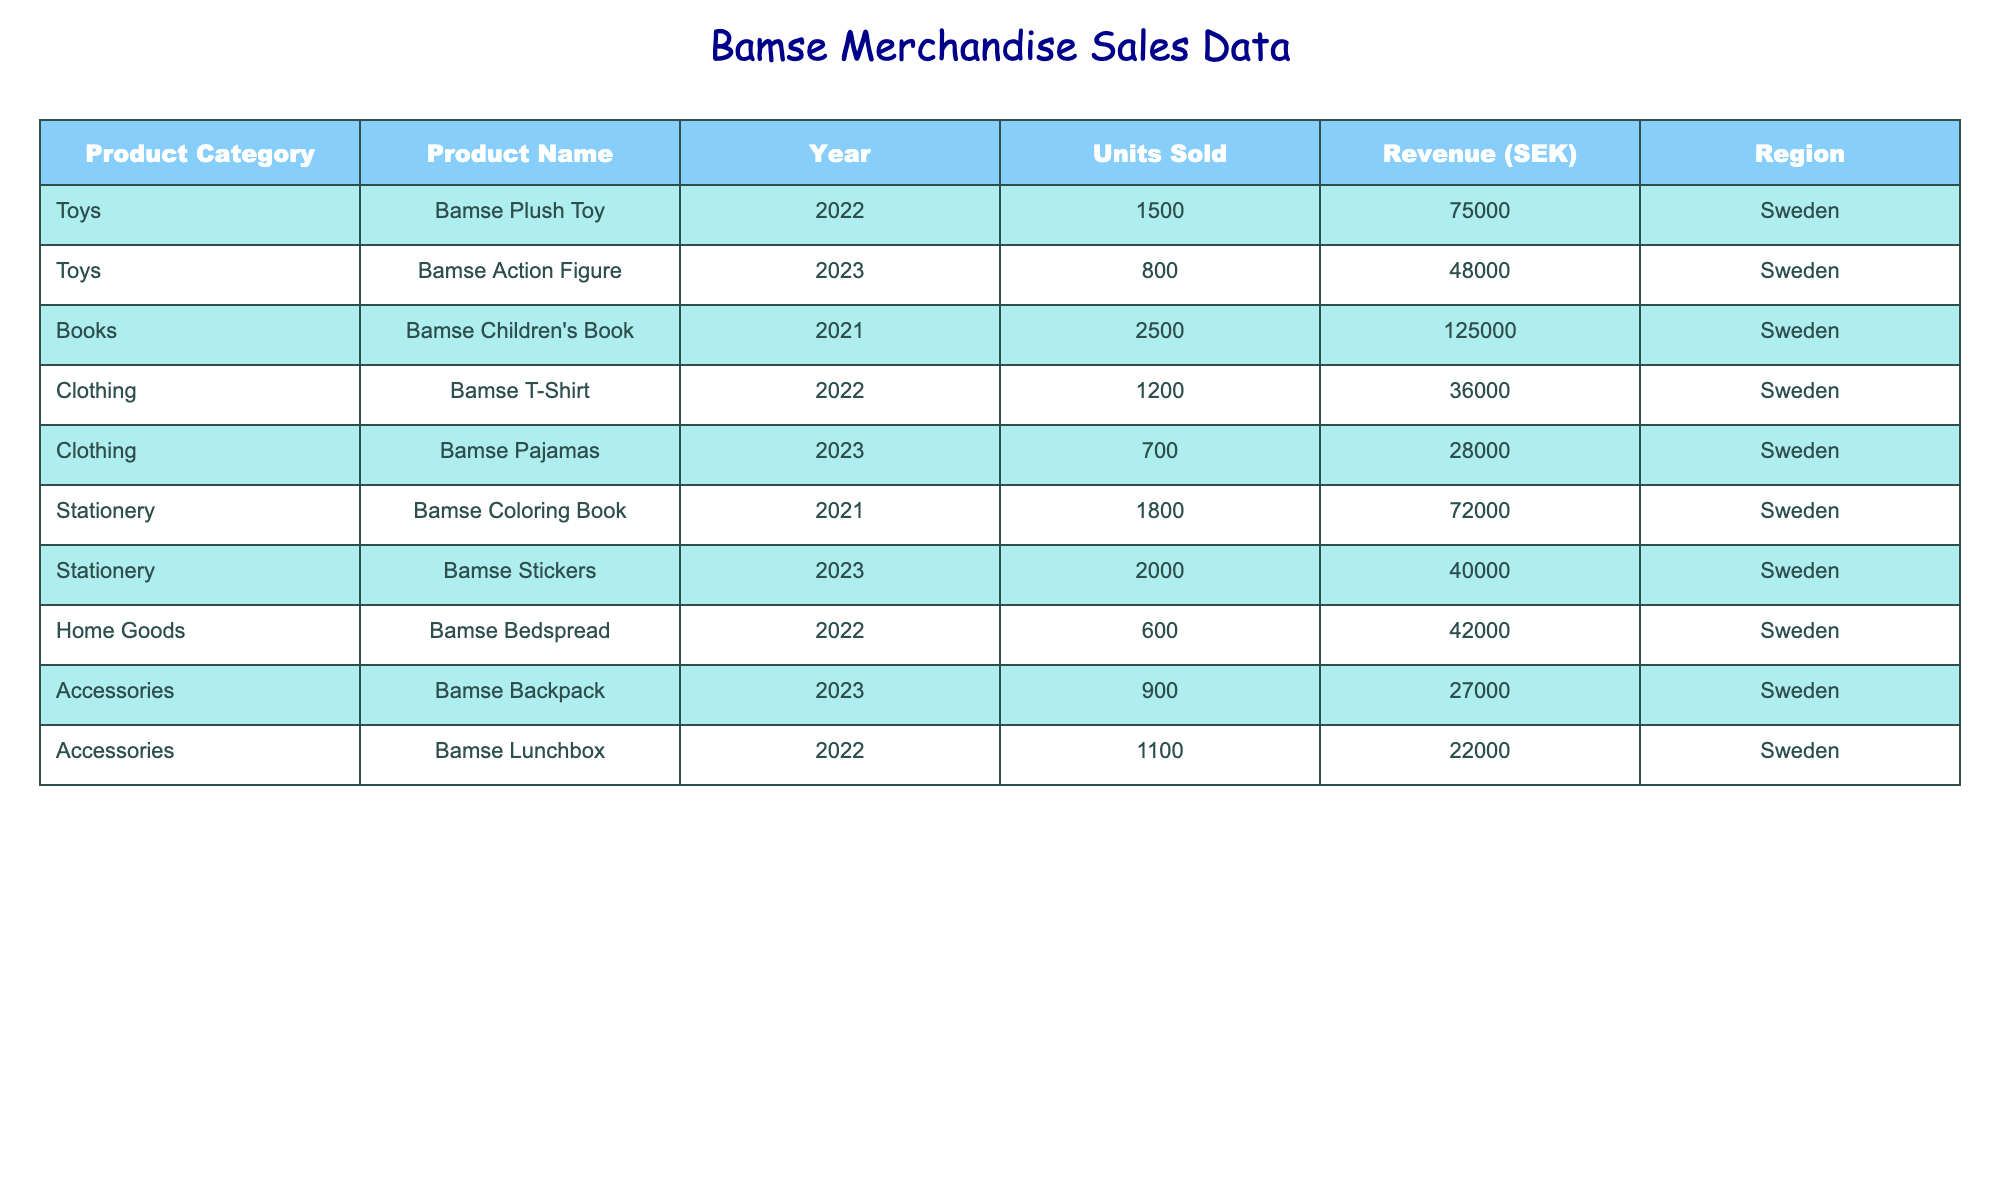What was the total revenue generated from the sale of Bamse pajamas in 2023? For the year 2023, the revenue generated from Bamse pajamas is listed as 28000 SEK. Thus, the total revenue for this product is simply the value given in the table.
Answer: 28000 SEK How many units of Bamse action figures were sold in Sweden in 2023? The table specifies that in 2023, 800 units of Bamse action figures were sold in Sweden, which can be directly retrieved from the relevant row.
Answer: 800 units Which Bamse-branded product generated the highest revenue in 2021? In 2021, the Bamse children's book sold 2500 units and generated 125000 SEK, which is the highest value in the revenue column for that year compared to the other products sold.
Answer: Bamse Children's Book What is the total number of units sold for all clothing items across the years? The total number of units sold for clothing items are Bamse T-Shirt (1200 units in 2022) and Bamse Pajamas (700 units in 2023). Adding these gives: 1200 + 700 = 1900 units sold in total.
Answer: 1900 units Did Bamse coloring books generate more revenue than Bamse plush toys in 2022? The revenue for Bamse coloring books in 2021 is 72000 SEK, and for Bamse plush toys in 2022, it is 75000 SEK. Since 75000 SEK is greater than 72000 SEK, the statement is false.
Answer: No What was the difference in revenue between Bamse stickers in 2023 and Bamse lunchboxes in 2022? Bamse stickers generated 40000 SEK in 2023, while Bamse lunchboxes generated 22000 SEK in 2022. The difference is calculated as 40000 - 22000 = 18000 SEK.
Answer: 18000 SEK Is it true that more total units of Bamse toys were sold in 2022 than in 2023? In 2022, Bamse toys had two products: Bamse Plush Toy (1500 units) and Bamse T-Shirt (1200 units), totaling 2700 units sold. In 2023, Bamse Action Figure sold 800 units and Bamse Pajamas sold 700 units, totaling 1500 units. Since 2700 is greater than 1500, the statement is true.
Answer: Yes What is the average revenue generated by all Bamse merchandise in 2022? In 2022, the revenue from Bamse merchandise includes the plush toy (75000 SEK), T-shirt (36000 SEK), pajamas (28000 SEK), and bedspread (42000 SEK). Summing these gives: 75000 + 36000 + 28000 + 42000 = 181000 SEK, and dividing by 4 products gives 181000 / 4 = 45250 SEK.
Answer: 45250 SEK 